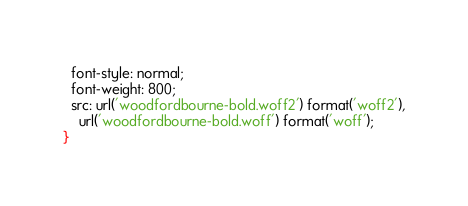Convert code to text. <code><loc_0><loc_0><loc_500><loc_500><_CSS_>  font-style: normal;
  font-weight: 800;
  src: url('woodfordbourne-bold.woff2') format('woff2'),
    url('woodfordbourne-bold.woff') format('woff');
}
</code> 